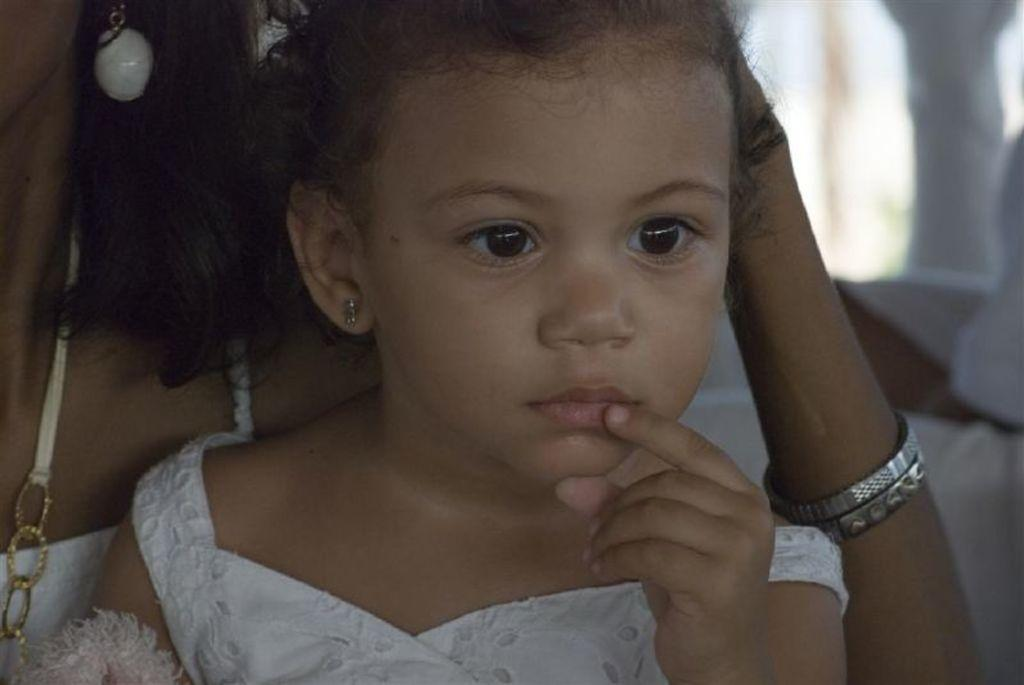What is the main subject of the image? There is a baby in the image. What is the baby wearing? The baby is wearing a white dress. Can you describe the other person in the image? There is another person in the background of the image, and they are also wearing a white dress. What type of base can be seen supporting the baby in the image? There is no base visible in the image; the baby is likely being held or sitting on a surface that is not visible in the image. 